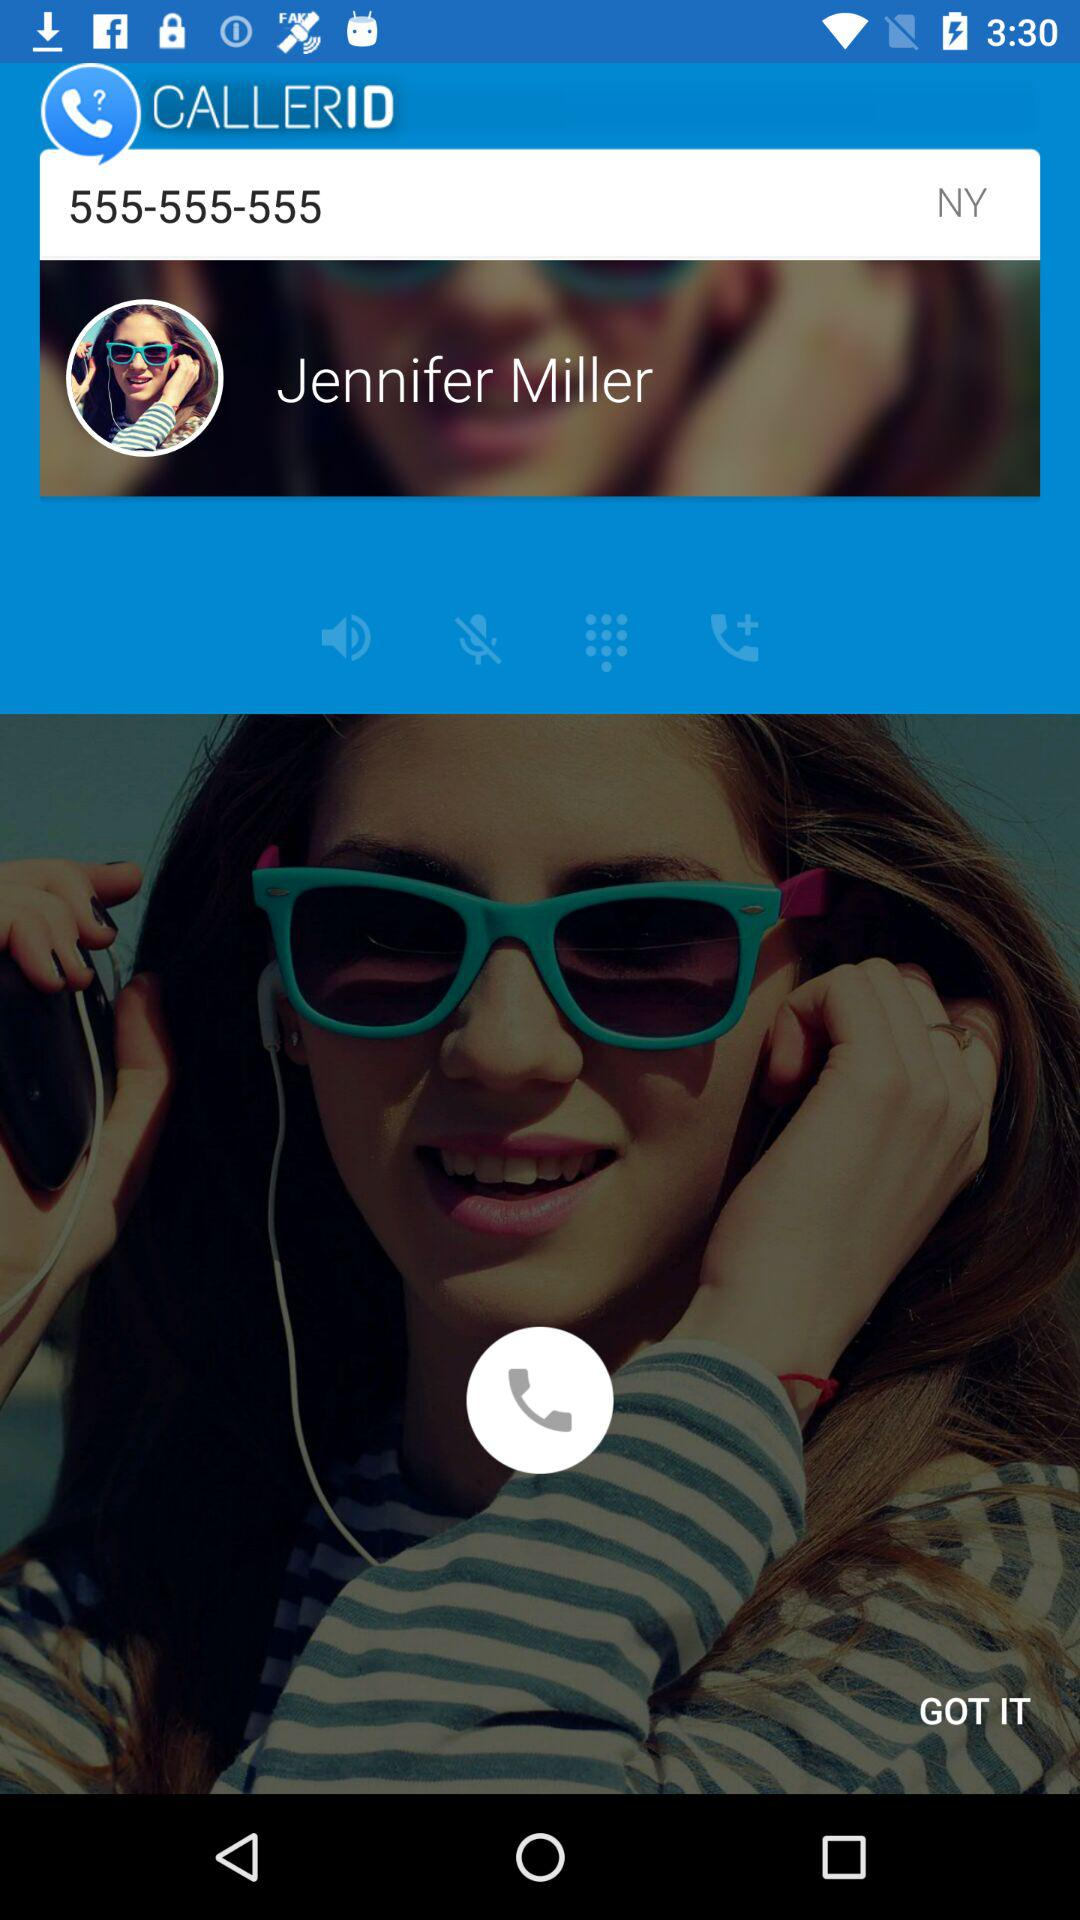What is the phone number? The phone number is 555-555-555. 